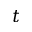<formula> <loc_0><loc_0><loc_500><loc_500>t</formula> 